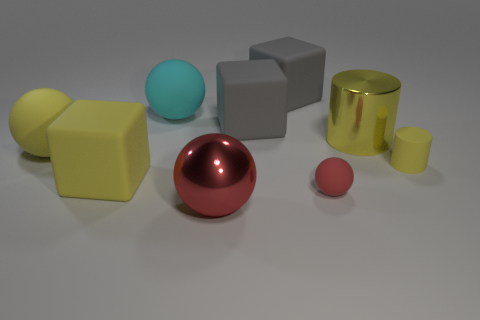What number of other things are there of the same color as the tiny ball?
Keep it short and to the point. 1. What material is the big cylinder?
Your answer should be compact. Metal. Does the matte thing that is right of the yellow metal cylinder have the same size as the large red sphere?
Your response must be concise. No. Is there any other thing that has the same size as the yellow rubber block?
Give a very brief answer. Yes. What is the size of the other object that is the same shape as the yellow shiny object?
Offer a very short reply. Small. Is the number of yellow rubber spheres that are behind the big cyan matte thing the same as the number of large gray blocks in front of the yellow shiny object?
Offer a very short reply. Yes. What is the size of the cylinder that is in front of the big yellow ball?
Your response must be concise. Small. Does the big cylinder have the same color as the small matte cylinder?
Offer a very short reply. Yes. Are there any other things that have the same shape as the large red metal object?
Your answer should be compact. Yes. What is the material of the large sphere that is the same color as the small rubber ball?
Offer a very short reply. Metal. 